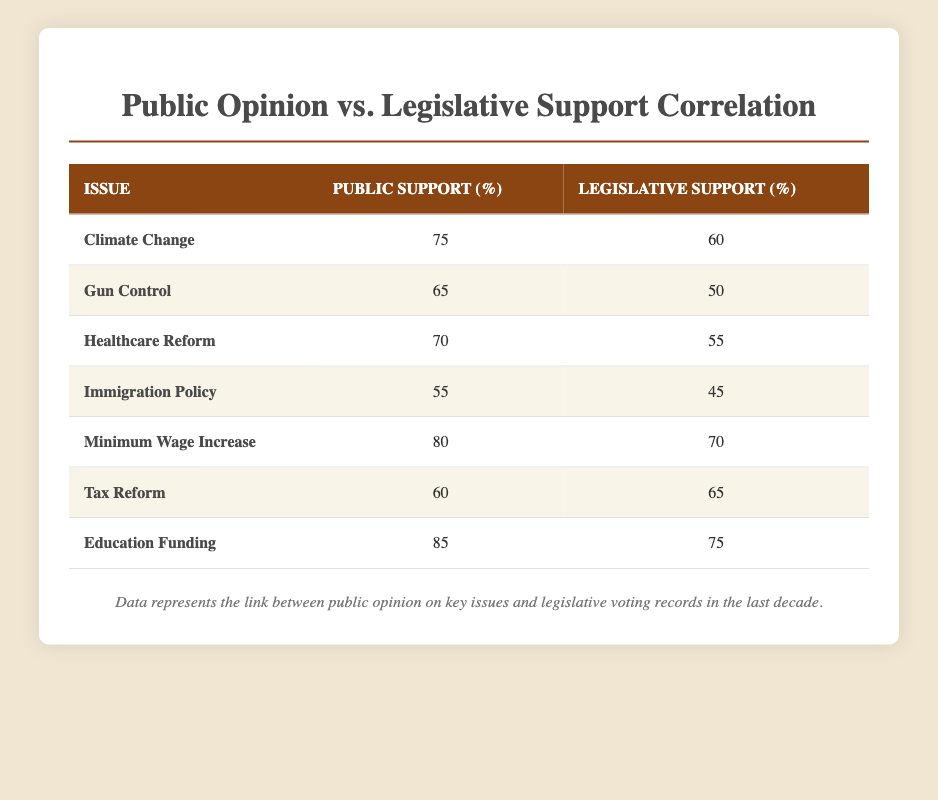What is the public support percentage for Education Funding? From the table, the public support for Education Funding is explicitly listed under the "Public Support (%)" column, showing a value of 85.
Answer: 85 What is the legislative support percentage for Gun Control? The table indicates that the legislative support for Gun Control is directly provided in the "Legislative Support (%)" column, which is 50.
Answer: 50 What is the difference between public support and legislative support for Climate Change? The public support for Climate Change is 75, while the legislative support is 60. Therefore, the difference is calculated as 75 - 60 = 15.
Answer: 15 Is the legislative support for Immigration Policy higher than the public support? The public support for Immigration Policy is 55 and legislative support is 45. Since 45 is less than 55, the answer is no.
Answer: No What is the average public support for all the issues listed? To calculate the average, sum the public support values: (75 + 65 + 70 + 55 + 80 + 60 + 85) = 490. Then divide by the number of issues, which is 7. So, 490 / 7 = 70.
Answer: 70 Which issue has the highest public support and what is the corresponding legislative support? By reviewing the public support percentages, Education Funding has the highest public support at 85. The corresponding legislative support for Education Funding is 75.
Answer: Education Funding, 75 How many issues have a legislative support percentage greater than their public support percentage? From the table, we need to compare each issue's legislative support to its public support. The only issue where legislative support is greater is Tax Reform (60 public vs. 65 legislative). Thus, there is only one instance.
Answer: 1 What is the total legislative support for all issues combined? To find the total legislative support, add the values: (60 + 50 + 55 + 45 + 70 + 65 + 75) = 420. Hence, the total is 420.
Answer: 420 Is there any issue where public support is less than 60%? Looking through the public support values, only Immigration Policy has a public support value of 55, which is less than 60. Therefore, the answer is yes.
Answer: Yes 